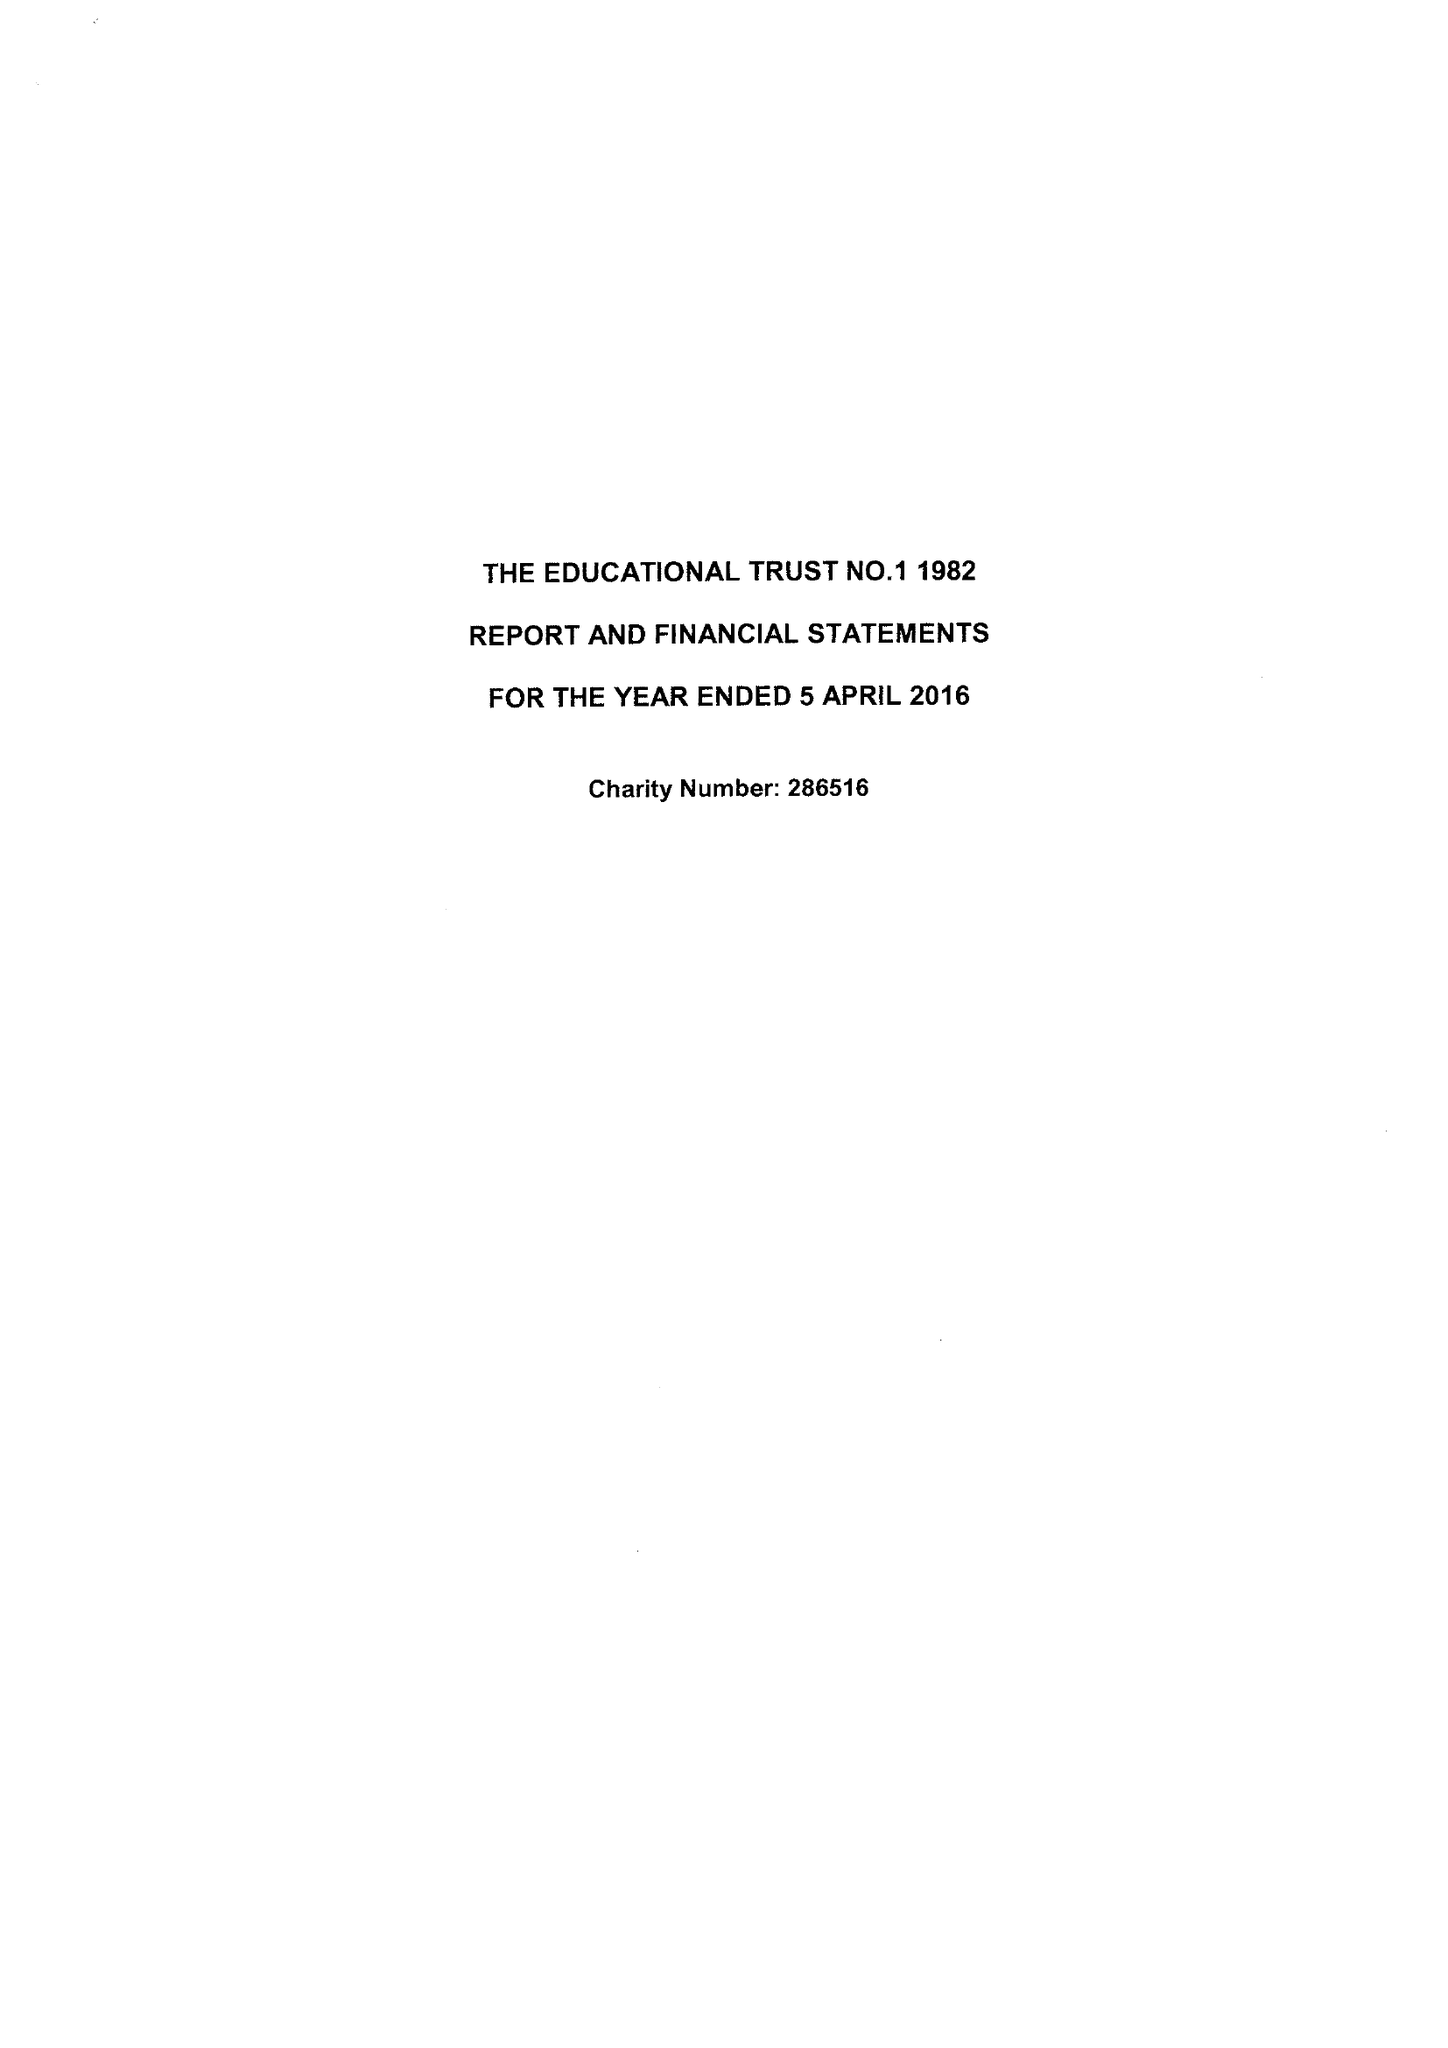What is the value for the report_date?
Answer the question using a single word or phrase. 2016-04-05 